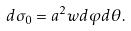<formula> <loc_0><loc_0><loc_500><loc_500>d \sigma _ { 0 } = a ^ { 2 } w d \varphi d \theta .</formula> 